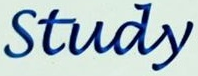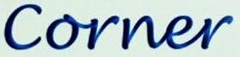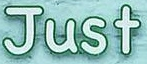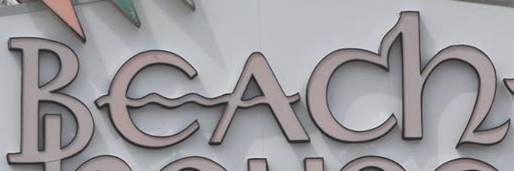What text is displayed in these images sequentially, separated by a semicolon? Study; Corner; Just; Beach 